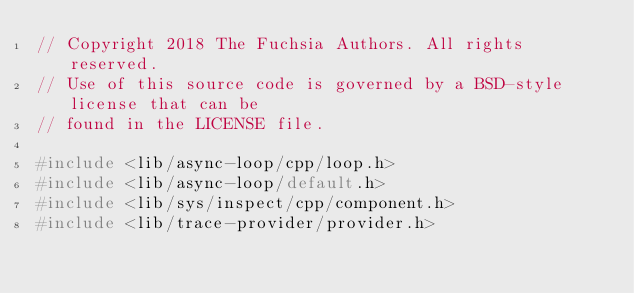<code> <loc_0><loc_0><loc_500><loc_500><_C++_>// Copyright 2018 The Fuchsia Authors. All rights reserved.
// Use of this source code is governed by a BSD-style license that can be
// found in the LICENSE file.

#include <lib/async-loop/cpp/loop.h>
#include <lib/async-loop/default.h>
#include <lib/sys/inspect/cpp/component.h>
#include <lib/trace-provider/provider.h></code> 